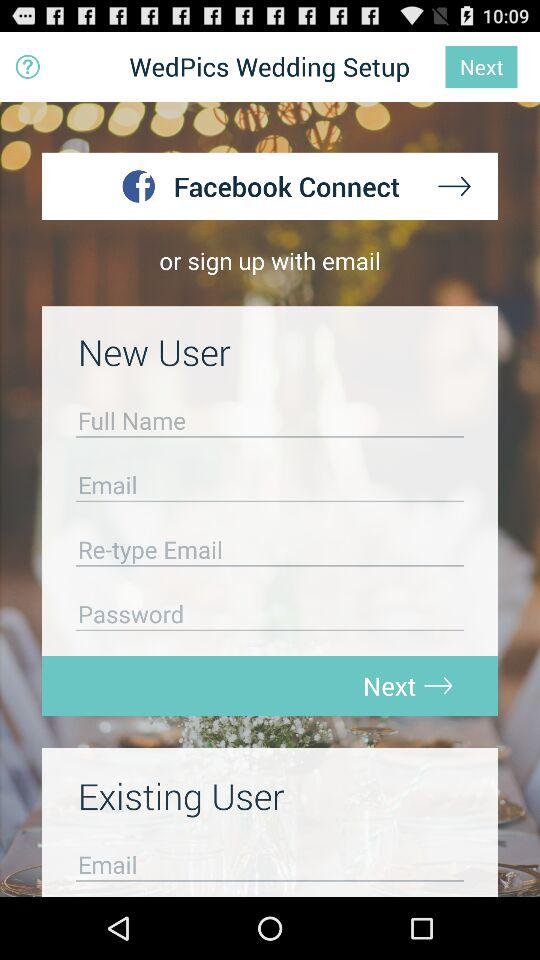What is the application name? The application name is "WedPics". 